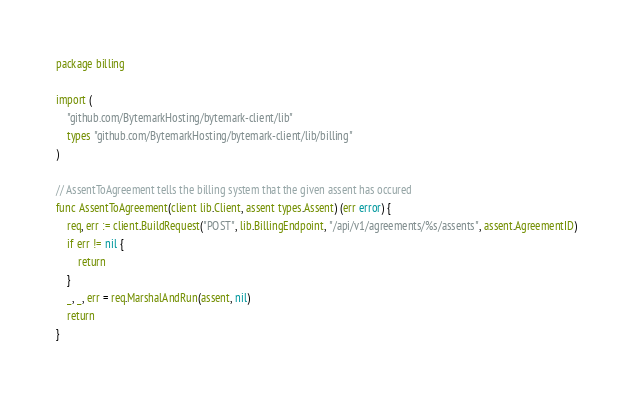Convert code to text. <code><loc_0><loc_0><loc_500><loc_500><_Go_>package billing

import (
	"github.com/BytemarkHosting/bytemark-client/lib"
	types "github.com/BytemarkHosting/bytemark-client/lib/billing"
)

// AssentToAgreement tells the billing system that the given assent has occured
func AssentToAgreement(client lib.Client, assent types.Assent) (err error) {
	req, err := client.BuildRequest("POST", lib.BillingEndpoint, "/api/v1/agreements/%s/assents", assent.AgreementID)
	if err != nil {
		return
	}
	_, _, err = req.MarshalAndRun(assent, nil)
	return
}
</code> 